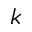Convert formula to latex. <formula><loc_0><loc_0><loc_500><loc_500>k</formula> 